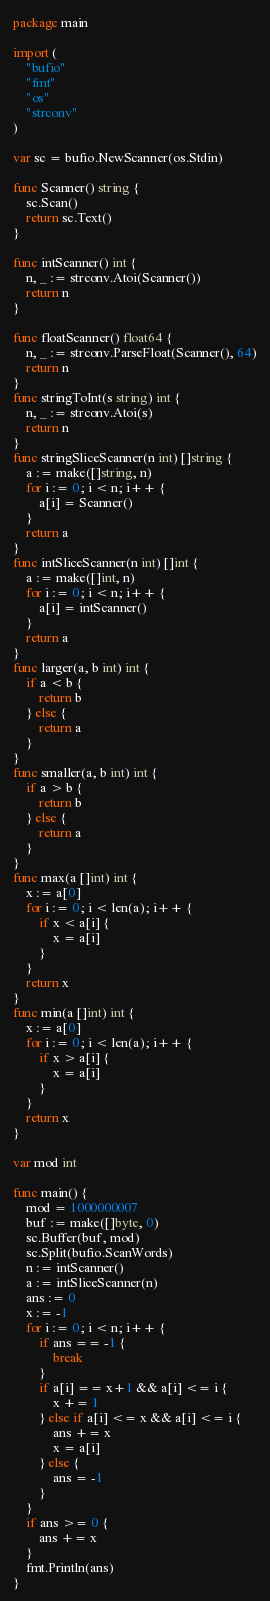<code> <loc_0><loc_0><loc_500><loc_500><_Go_>package main

import (
	"bufio"
	"fmt"
	"os"
	"strconv"
)

var sc = bufio.NewScanner(os.Stdin)

func Scanner() string {
	sc.Scan()
	return sc.Text()
}

func intScanner() int {
	n, _ := strconv.Atoi(Scanner())
	return n
}

func floatScanner() float64 {
	n, _ := strconv.ParseFloat(Scanner(), 64)
	return n
}
func stringToInt(s string) int {
	n, _ := strconv.Atoi(s)
	return n
}
func stringSliceScanner(n int) []string {
	a := make([]string, n)
	for i := 0; i < n; i++ {
		a[i] = Scanner()
	}
	return a
}
func intSliceScanner(n int) []int {
	a := make([]int, n)
	for i := 0; i < n; i++ {
		a[i] = intScanner()
	}
	return a
}
func larger(a, b int) int {
	if a < b {
		return b
	} else {
		return a
	}
}
func smaller(a, b int) int {
	if a > b {
		return b
	} else {
		return a
	}
}
func max(a []int) int {
	x := a[0]
	for i := 0; i < len(a); i++ {
		if x < a[i] {
			x = a[i]
		}
	}
	return x
}
func min(a []int) int {
	x := a[0]
	for i := 0; i < len(a); i++ {
		if x > a[i] {
			x = a[i]
		}
	}
	return x
}

var mod int

func main() {
	mod = 1000000007
	buf := make([]byte, 0)
	sc.Buffer(buf, mod)
	sc.Split(bufio.ScanWords)
	n := intScanner()
	a := intSliceScanner(n)
	ans := 0
	x := -1
	for i := 0; i < n; i++ {
		if ans == -1 {
			break
		}
		if a[i] == x+1 && a[i] <= i {
			x += 1
		} else if a[i] <= x && a[i] <= i {
			ans += x
			x = a[i]
		} else {
			ans = -1
		}
	}
	if ans >= 0 {
		ans += x
	}
	fmt.Println(ans)
}
</code> 